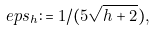Convert formula to latex. <formula><loc_0><loc_0><loc_500><loc_500>\ e p s _ { h } \colon = 1 / ( 5 \sqrt { h + 2 } ) ,</formula> 